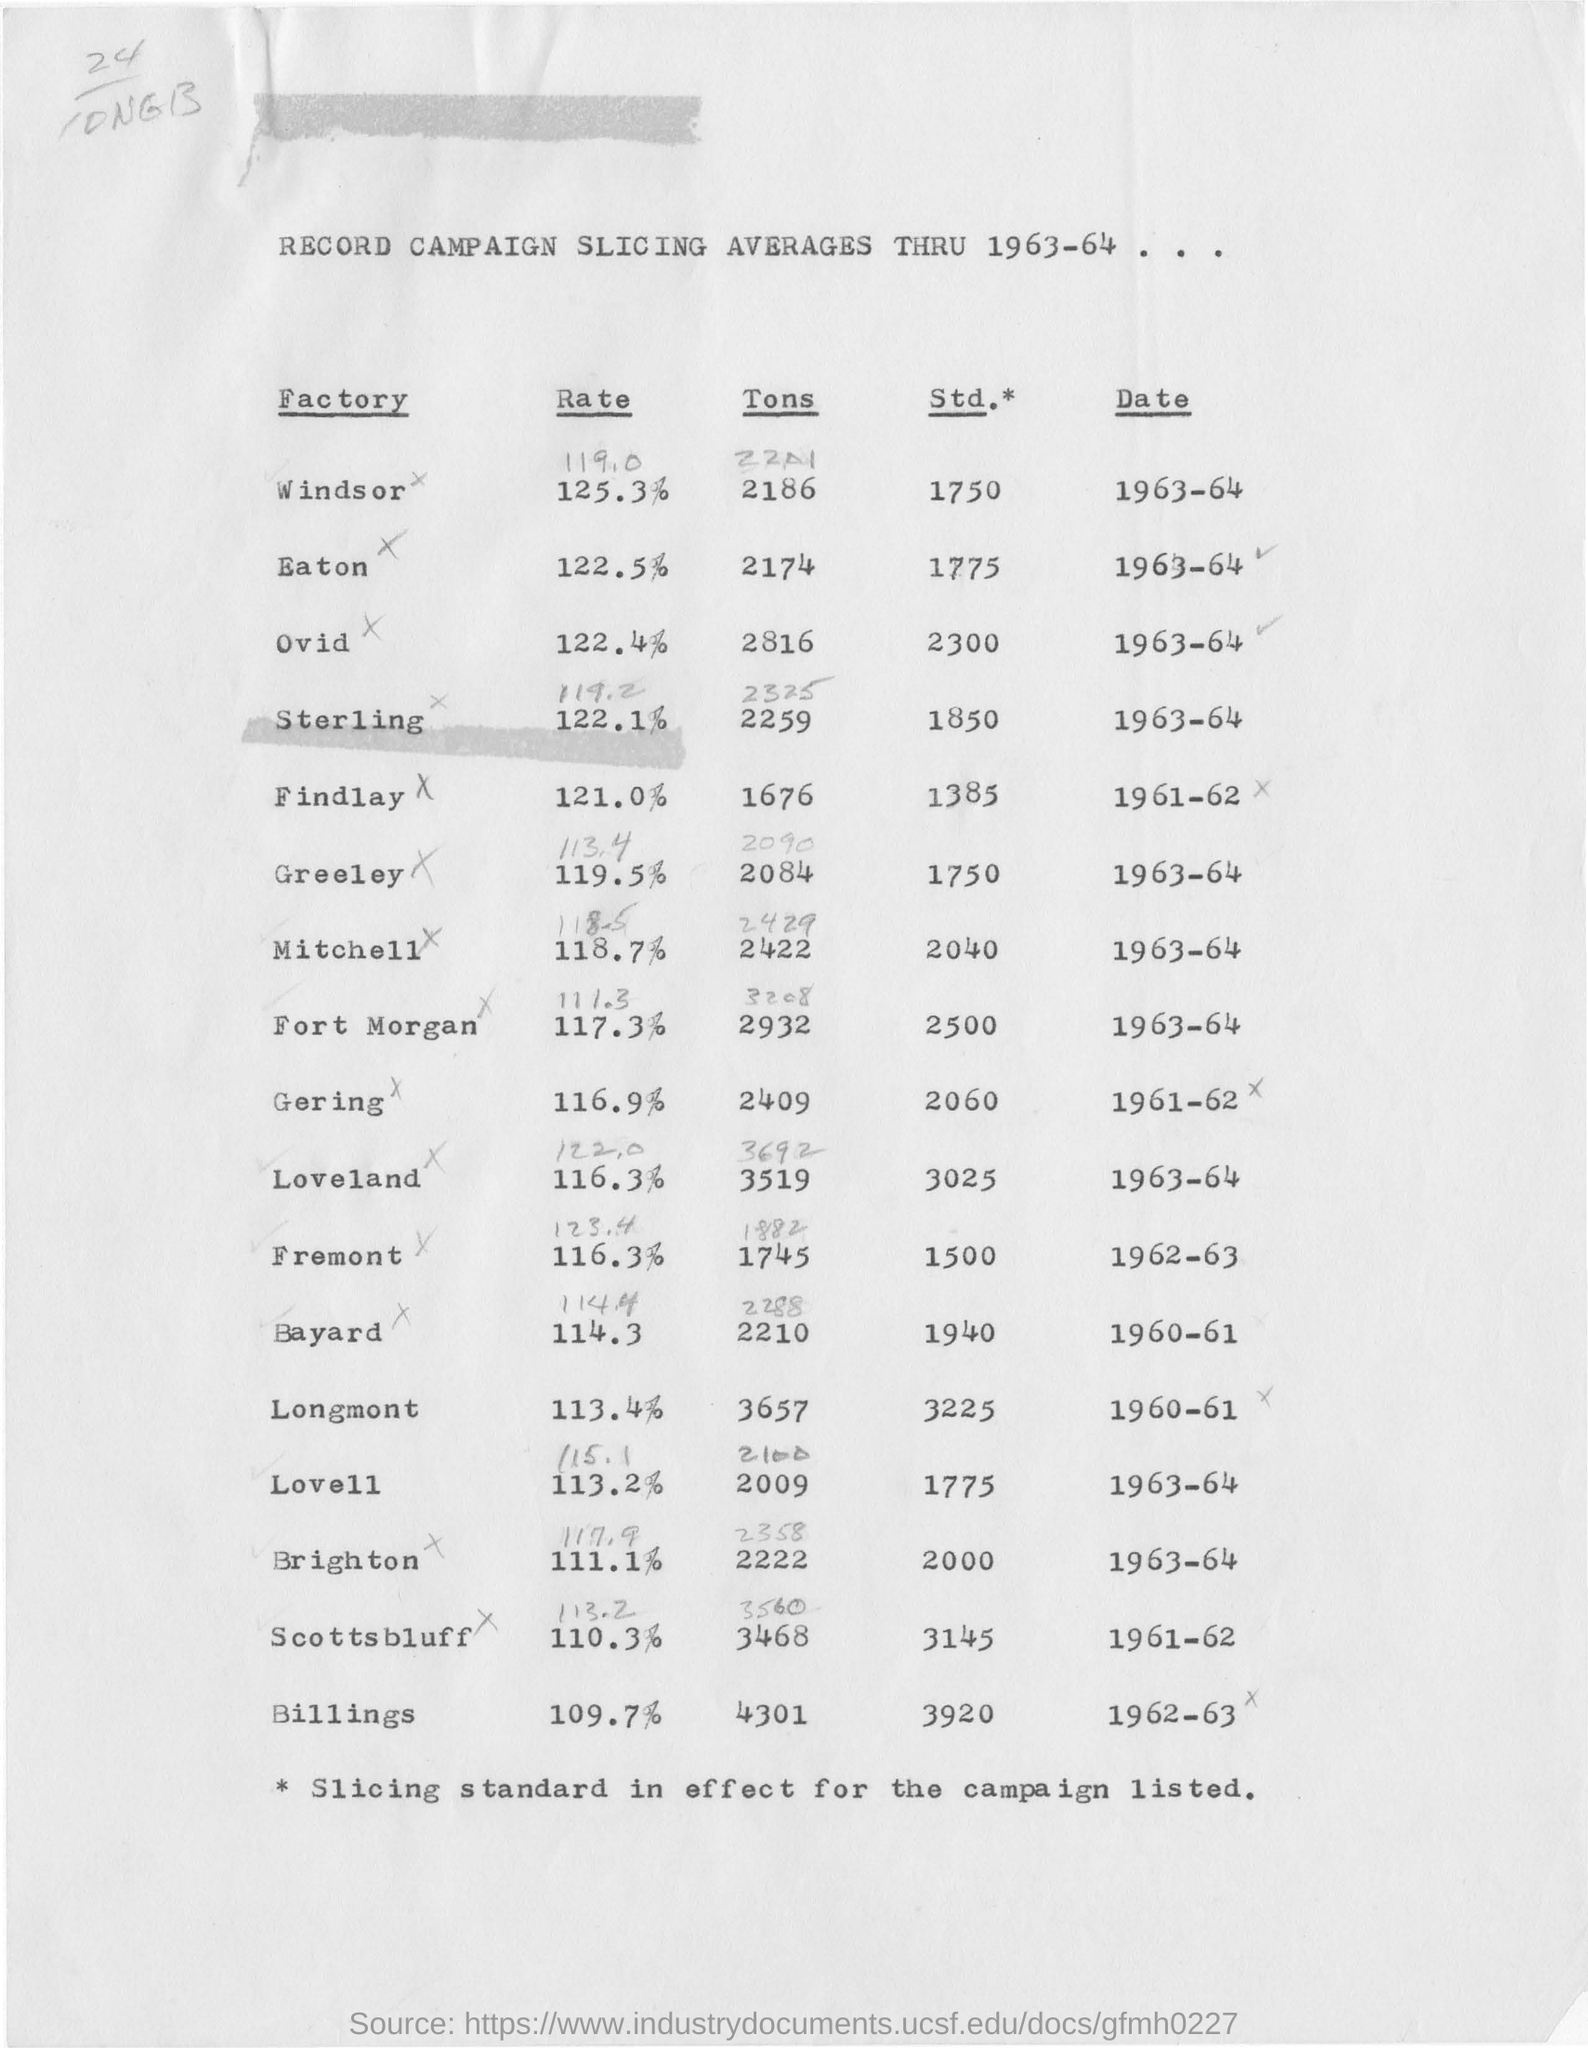List a handful of essential elements in this visual. This document provides an overview of campaign average slicing from 1963 to 1964. 